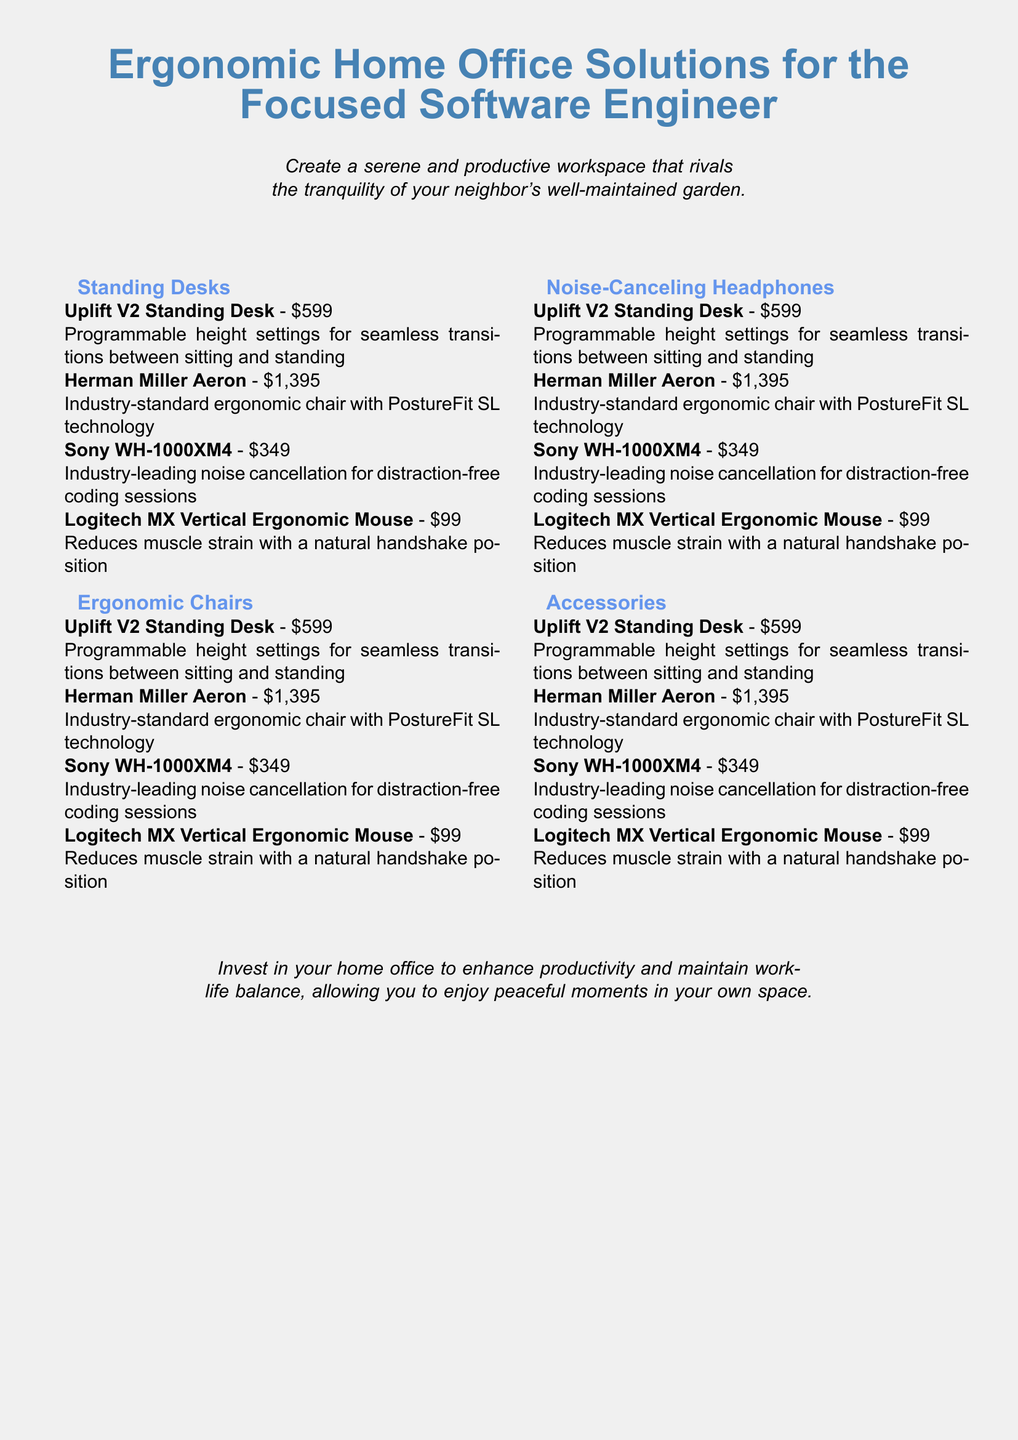What is the title of the document? The title is prominently displayed at the beginning of the document as the focus of the catalog.
Answer: Ergonomic Home Office Solutions for the Focused Software Engineer How many categories are listed? The document outlines four specific categories of ergonomic equipment for home offices.
Answer: 4 What is the price of the Herman Miller Aeron chair? The price is detailed next to the product name in the item list of the catalog.
Answer: $1,395 What feature does the Sony WH-1000XM4 headphones provide? The catalog highlights a specific quality of the headphones that assists software engineers during work.
Answer: Noise cancellation Which product is described as having programmable height settings? This product is mentioned in the standing desks category for its specific design.
Answer: Uplift V2 Standing Desk What is the purpose of investing in a home office according to the document? The document discusses the benefits of enhancing one’s workspace in a brief statement.
Answer: Enhance productivity Which ergonomic mouse is mentioned? The catalog specifies the ergonomic mouse that helps reduce muscle strain.
Answer: Logitech MX Vertical Ergonomic Mouse What aspect of the workspace does the document compare to a neighbor's garden? This comparison is made to emphasize the desired quality of the workspace described within the catalog.
Answer: Serenity 